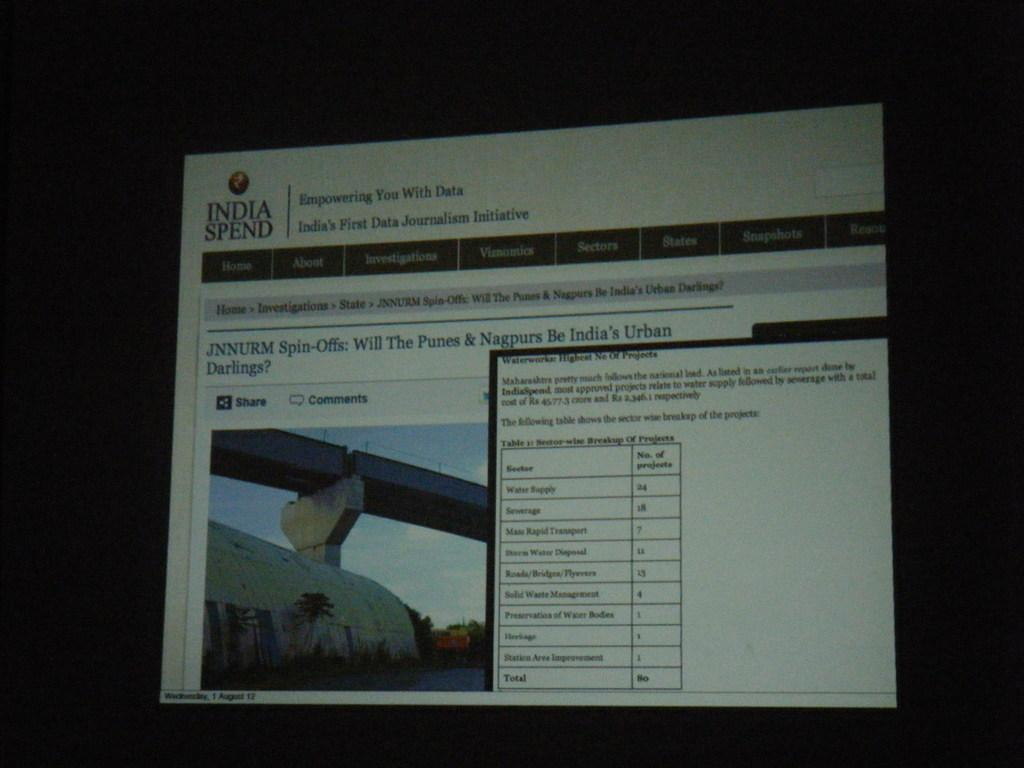<image>
Offer a succinct explanation of the picture presented. India Spend page is open and has a lot of imformation available 